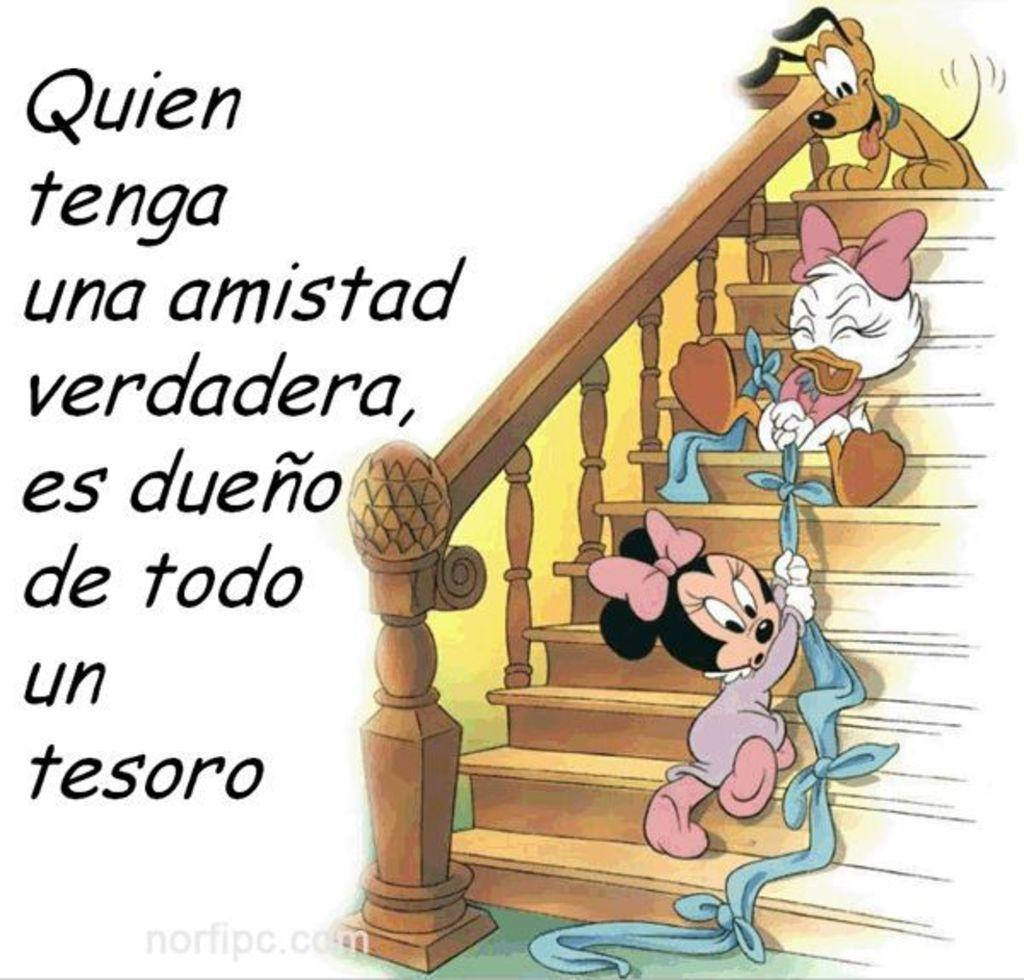What is on the stairs in the image? There are cartoons on the stairs. What else can be seen in the image besides the cartoons on the stairs? There is text visible in the image. Reasoning: Let' Let's think step by step in order to produce the conversation. We start by identifying the main subjects and objects in the image based on the provided facts. We then formulate questions that focus on the location and characteristics of these subjects and objects, ensuring that each question can be answered definitively with the information given. We avoid yes/no questions and ensure that the language is simple and clear. Absurd Question/Answer: What type of pollution can be seen in the image? There is no pollution visible in the image. How does the hook affect the cartoons on the stairs? There is no hook present in the image. What type of mist can be seen in the image? There is no mist visible in the image. How does the hook affect the cartoons on the stairs? There is no hook present in the image. 